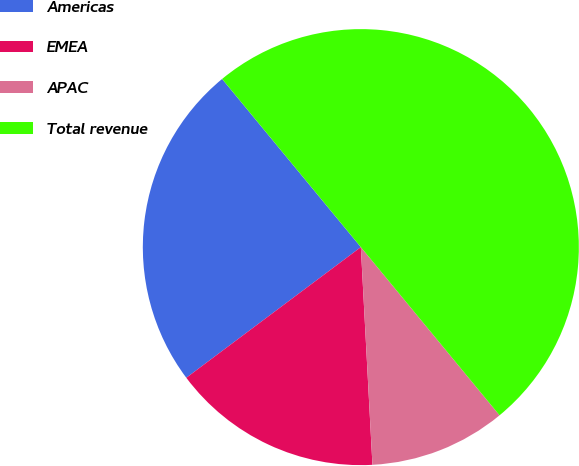Convert chart to OTSL. <chart><loc_0><loc_0><loc_500><loc_500><pie_chart><fcel>Americas<fcel>EMEA<fcel>APAC<fcel>Total revenue<nl><fcel>24.25%<fcel>15.62%<fcel>10.13%<fcel>50.0%<nl></chart> 